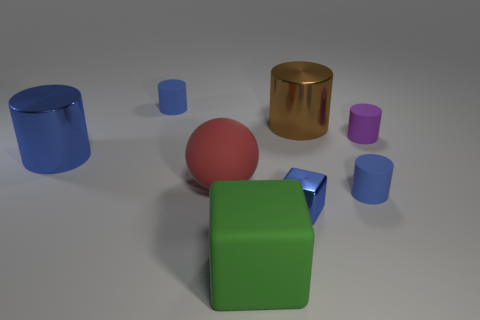Subtract all blue cylinders. How many were subtracted if there are1blue cylinders left? 2 Subtract all cyan cubes. How many blue cylinders are left? 3 Subtract all purple matte cylinders. How many cylinders are left? 4 Subtract all brown cylinders. How many cylinders are left? 4 Subtract all gray cylinders. Subtract all blue balls. How many cylinders are left? 5 Add 2 big metal cylinders. How many objects exist? 10 Subtract all balls. How many objects are left? 7 Add 2 tiny brown matte spheres. How many tiny brown matte spheres exist? 2 Subtract 0 brown blocks. How many objects are left? 8 Subtract all green rubber things. Subtract all tiny rubber cylinders. How many objects are left? 4 